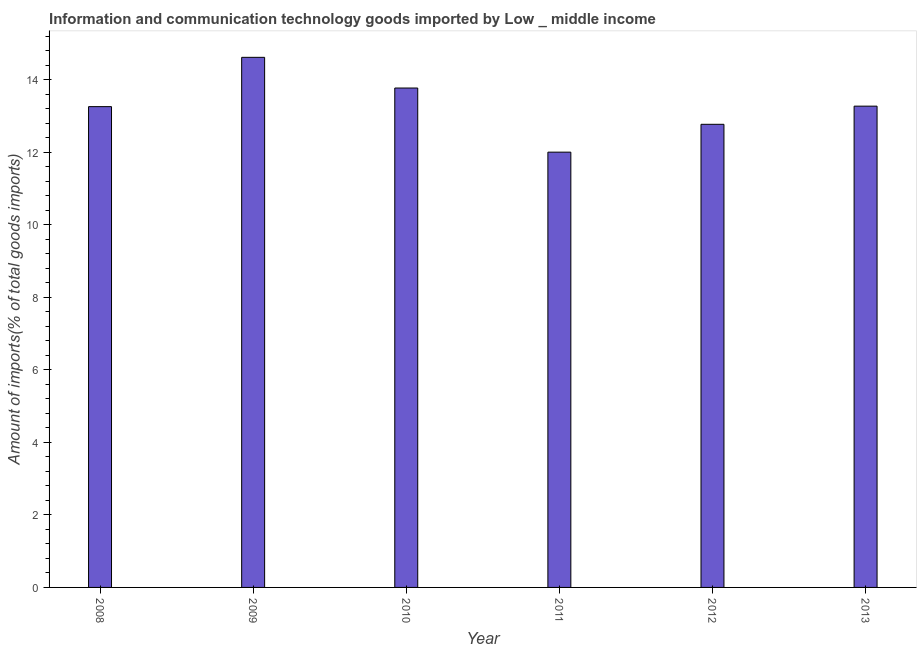What is the title of the graph?
Ensure brevity in your answer.  Information and communication technology goods imported by Low _ middle income. What is the label or title of the Y-axis?
Your answer should be very brief. Amount of imports(% of total goods imports). What is the amount of ict goods imports in 2008?
Ensure brevity in your answer.  13.25. Across all years, what is the maximum amount of ict goods imports?
Offer a very short reply. 14.61. Across all years, what is the minimum amount of ict goods imports?
Your answer should be compact. 12. In which year was the amount of ict goods imports minimum?
Give a very brief answer. 2011. What is the sum of the amount of ict goods imports?
Make the answer very short. 79.67. What is the difference between the amount of ict goods imports in 2011 and 2012?
Your response must be concise. -0.77. What is the average amount of ict goods imports per year?
Offer a very short reply. 13.28. What is the median amount of ict goods imports?
Give a very brief answer. 13.26. In how many years, is the amount of ict goods imports greater than 5.6 %?
Your answer should be compact. 6. What is the ratio of the amount of ict goods imports in 2012 to that in 2013?
Provide a short and direct response. 0.96. What is the difference between the highest and the second highest amount of ict goods imports?
Give a very brief answer. 0.85. What is the difference between the highest and the lowest amount of ict goods imports?
Ensure brevity in your answer.  2.61. What is the difference between two consecutive major ticks on the Y-axis?
Make the answer very short. 2. What is the Amount of imports(% of total goods imports) of 2008?
Your answer should be very brief. 13.25. What is the Amount of imports(% of total goods imports) of 2009?
Offer a very short reply. 14.61. What is the Amount of imports(% of total goods imports) in 2010?
Provide a short and direct response. 13.77. What is the Amount of imports(% of total goods imports) in 2011?
Provide a succinct answer. 12. What is the Amount of imports(% of total goods imports) in 2012?
Offer a very short reply. 12.77. What is the Amount of imports(% of total goods imports) of 2013?
Your answer should be very brief. 13.27. What is the difference between the Amount of imports(% of total goods imports) in 2008 and 2009?
Offer a terse response. -1.36. What is the difference between the Amount of imports(% of total goods imports) in 2008 and 2010?
Give a very brief answer. -0.51. What is the difference between the Amount of imports(% of total goods imports) in 2008 and 2011?
Your answer should be very brief. 1.25. What is the difference between the Amount of imports(% of total goods imports) in 2008 and 2012?
Provide a short and direct response. 0.49. What is the difference between the Amount of imports(% of total goods imports) in 2008 and 2013?
Offer a very short reply. -0.01. What is the difference between the Amount of imports(% of total goods imports) in 2009 and 2010?
Provide a short and direct response. 0.85. What is the difference between the Amount of imports(% of total goods imports) in 2009 and 2011?
Ensure brevity in your answer.  2.61. What is the difference between the Amount of imports(% of total goods imports) in 2009 and 2012?
Keep it short and to the point. 1.85. What is the difference between the Amount of imports(% of total goods imports) in 2009 and 2013?
Make the answer very short. 1.35. What is the difference between the Amount of imports(% of total goods imports) in 2010 and 2011?
Make the answer very short. 1.77. What is the difference between the Amount of imports(% of total goods imports) in 2010 and 2012?
Ensure brevity in your answer.  1. What is the difference between the Amount of imports(% of total goods imports) in 2010 and 2013?
Give a very brief answer. 0.5. What is the difference between the Amount of imports(% of total goods imports) in 2011 and 2012?
Give a very brief answer. -0.77. What is the difference between the Amount of imports(% of total goods imports) in 2011 and 2013?
Offer a very short reply. -1.27. What is the difference between the Amount of imports(% of total goods imports) in 2012 and 2013?
Provide a short and direct response. -0.5. What is the ratio of the Amount of imports(% of total goods imports) in 2008 to that in 2009?
Your answer should be compact. 0.91. What is the ratio of the Amount of imports(% of total goods imports) in 2008 to that in 2011?
Your answer should be very brief. 1.1. What is the ratio of the Amount of imports(% of total goods imports) in 2008 to that in 2012?
Keep it short and to the point. 1.04. What is the ratio of the Amount of imports(% of total goods imports) in 2009 to that in 2010?
Your answer should be compact. 1.06. What is the ratio of the Amount of imports(% of total goods imports) in 2009 to that in 2011?
Your response must be concise. 1.22. What is the ratio of the Amount of imports(% of total goods imports) in 2009 to that in 2012?
Ensure brevity in your answer.  1.15. What is the ratio of the Amount of imports(% of total goods imports) in 2009 to that in 2013?
Give a very brief answer. 1.1. What is the ratio of the Amount of imports(% of total goods imports) in 2010 to that in 2011?
Ensure brevity in your answer.  1.15. What is the ratio of the Amount of imports(% of total goods imports) in 2010 to that in 2012?
Provide a short and direct response. 1.08. What is the ratio of the Amount of imports(% of total goods imports) in 2010 to that in 2013?
Provide a succinct answer. 1.04. What is the ratio of the Amount of imports(% of total goods imports) in 2011 to that in 2013?
Give a very brief answer. 0.9. What is the ratio of the Amount of imports(% of total goods imports) in 2012 to that in 2013?
Provide a short and direct response. 0.96. 